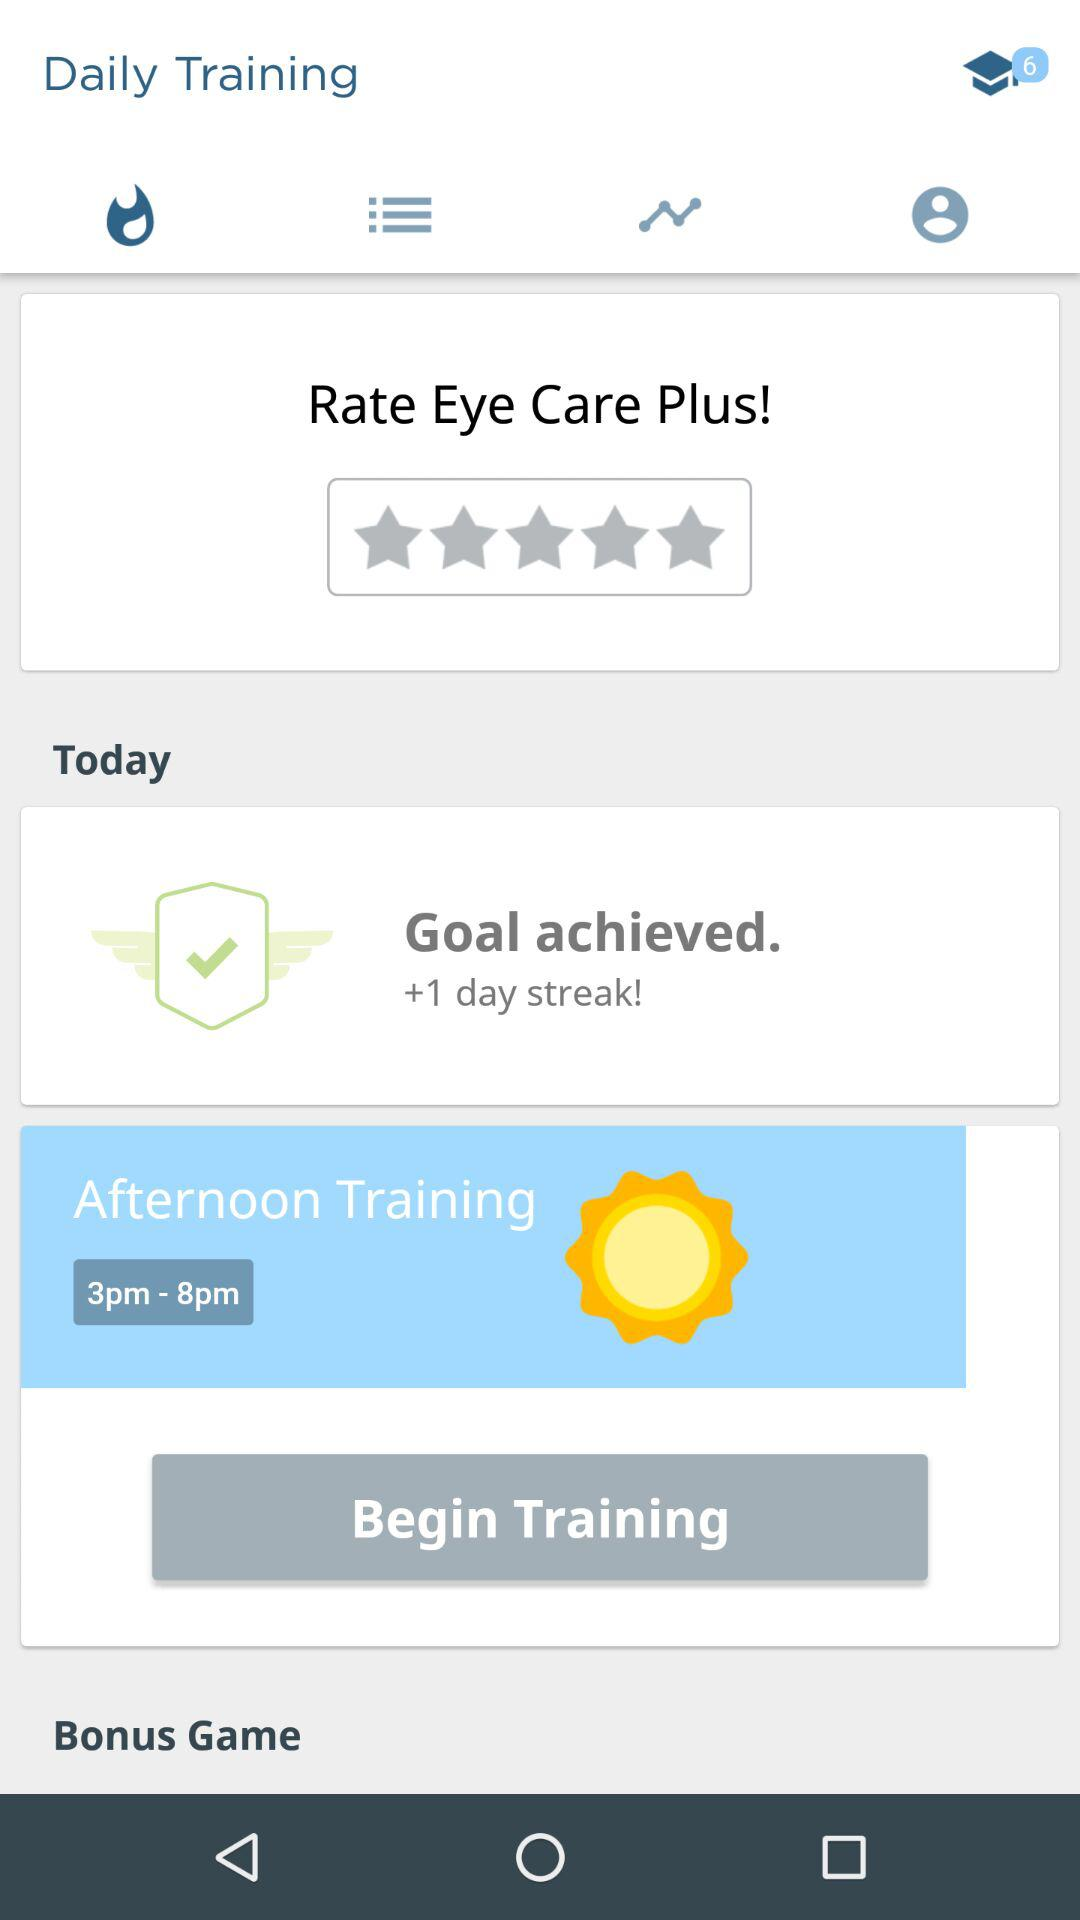What is the timing of afternoon training? The timing is from 3 p.m. to 8 p.m. 